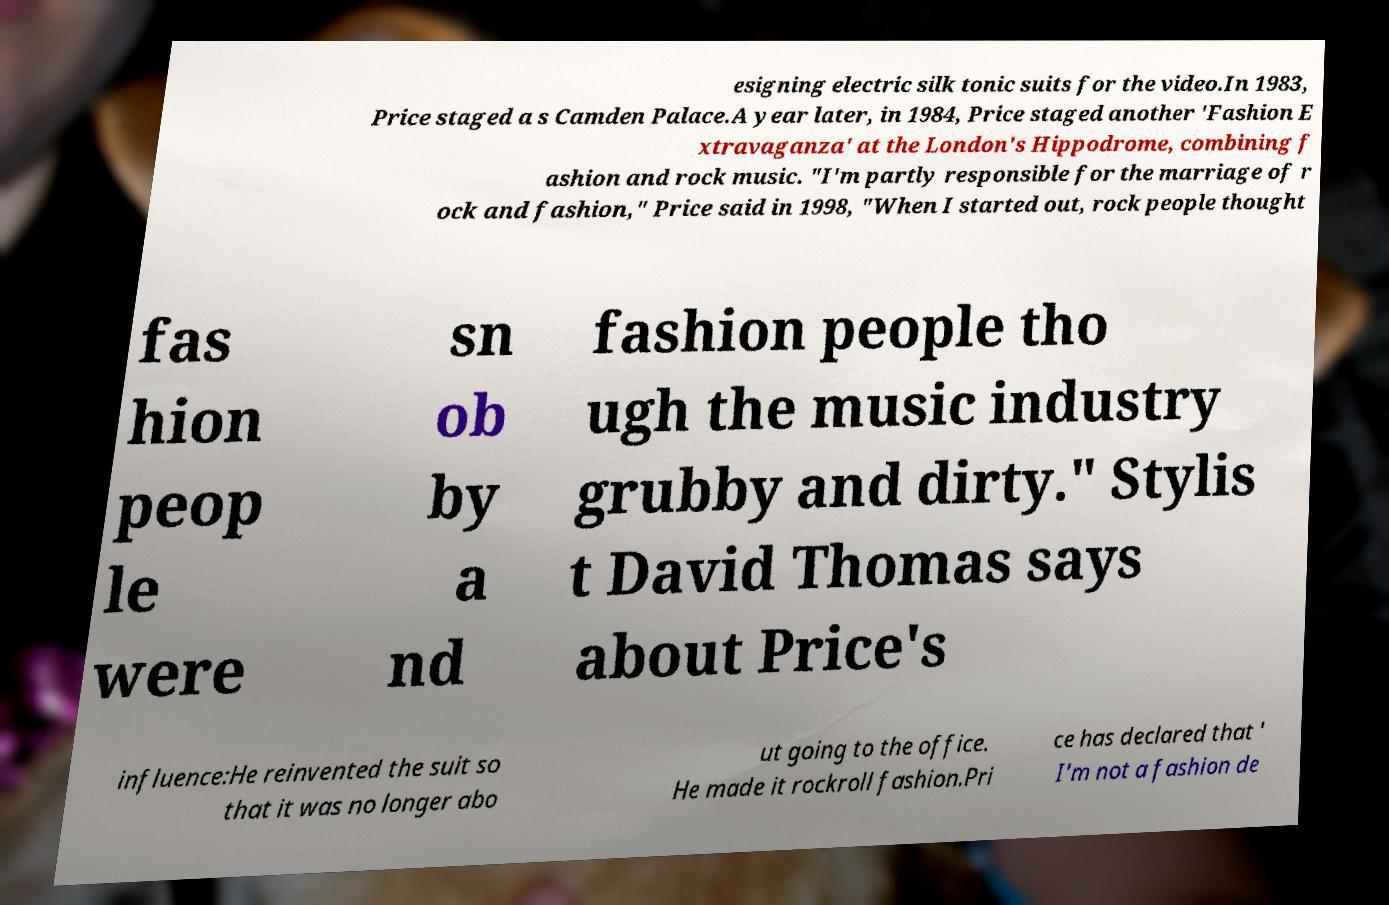I need the written content from this picture converted into text. Can you do that? esigning electric silk tonic suits for the video.In 1983, Price staged a s Camden Palace.A year later, in 1984, Price staged another 'Fashion E xtravaganza' at the London's Hippodrome, combining f ashion and rock music. "I'm partly responsible for the marriage of r ock and fashion," Price said in 1998, "When I started out, rock people thought fas hion peop le were sn ob by a nd fashion people tho ugh the music industry grubby and dirty." Stylis t David Thomas says about Price's influence:He reinvented the suit so that it was no longer abo ut going to the office. He made it rockroll fashion.Pri ce has declared that ' I'm not a fashion de 